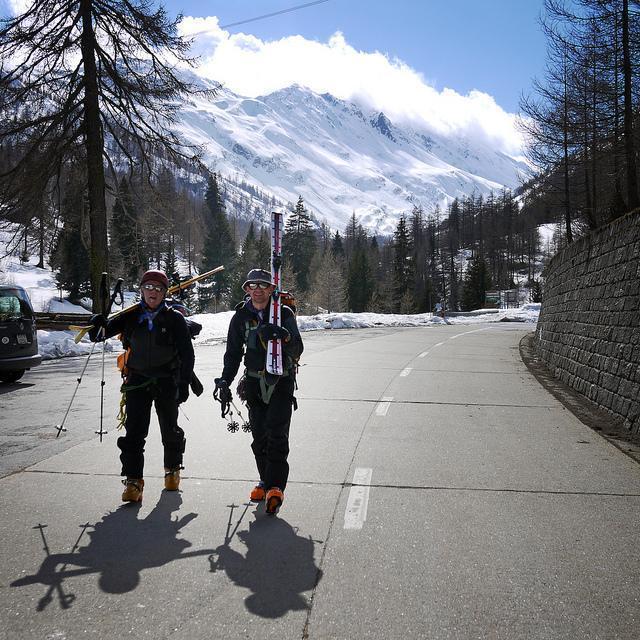The men here prefer to stop at which elevation to start their day of fun?
Choose the correct response, then elucidate: 'Answer: answer
Rationale: rationale.'
Options: Here, lower, higher, same. Answer: higher.
Rationale: They have skiing gear with them and skiers tend to ski from a high elevation to a lower height. 